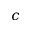Convert formula to latex. <formula><loc_0><loc_0><loc_500><loc_500>c</formula> 